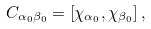Convert formula to latex. <formula><loc_0><loc_0><loc_500><loc_500>C _ { \alpha _ { 0 } \beta _ { 0 } } = \left [ \chi _ { \alpha _ { 0 } } , \chi _ { \beta _ { 0 } } \right ] ,</formula> 